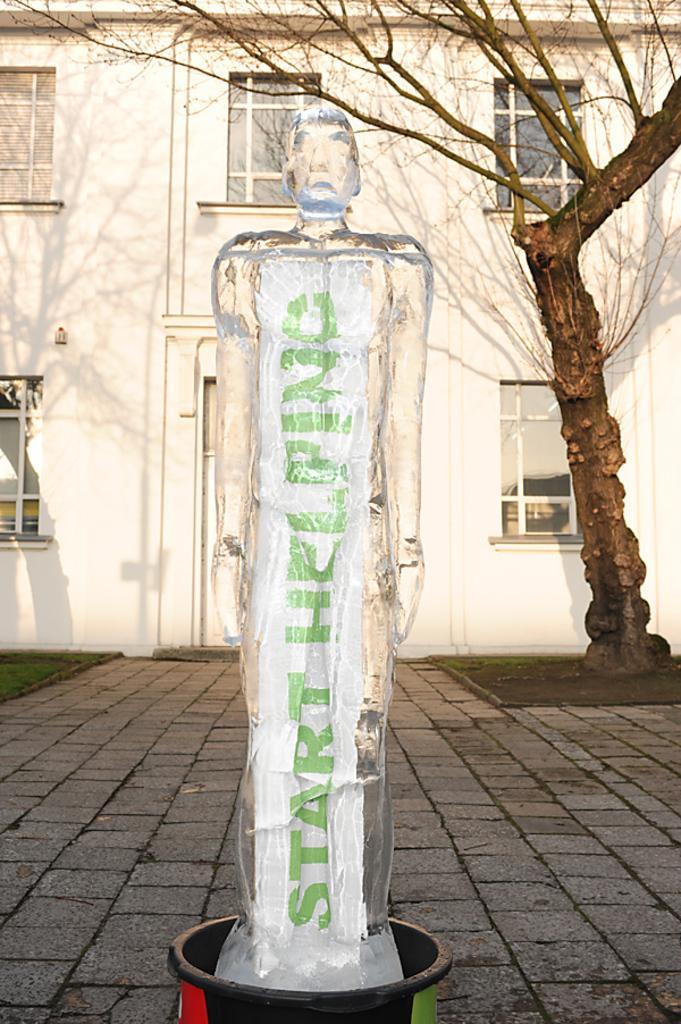How would you summarize this image in a sentence or two? In this image in front there is a statue. Behind the statue there is a tree. There are glass windows and there is a building. At the bottom of the image there is a floor. 